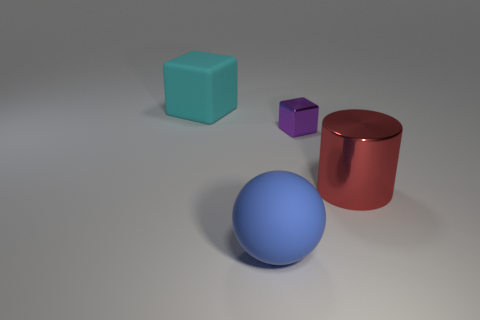Add 2 big cyan objects. How many objects exist? 6 Subtract all purple blocks. How many blocks are left? 1 Subtract 0 purple cylinders. How many objects are left? 4 Subtract all spheres. How many objects are left? 3 Subtract 1 spheres. How many spheres are left? 0 Subtract all purple cylinders. Subtract all cyan balls. How many cylinders are left? 1 Subtract all gray cylinders. How many yellow blocks are left? 0 Subtract all brown cubes. Subtract all large metal things. How many objects are left? 3 Add 1 big cylinders. How many big cylinders are left? 2 Add 1 big red cylinders. How many big red cylinders exist? 2 